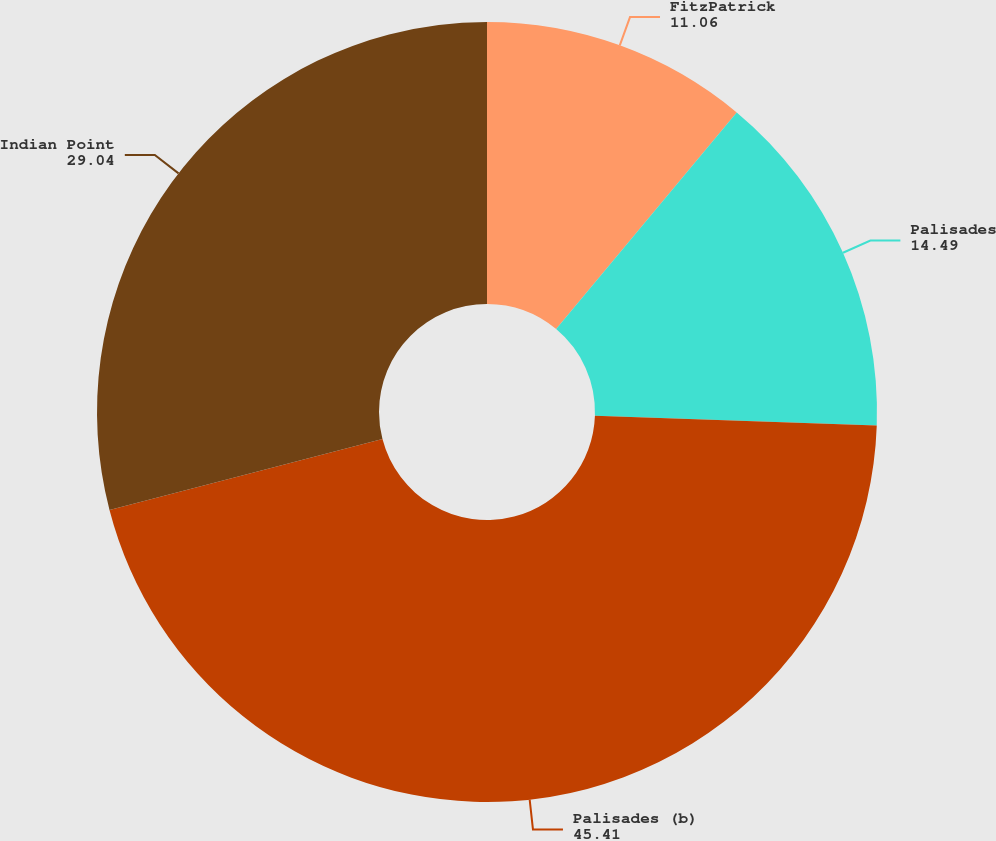Convert chart to OTSL. <chart><loc_0><loc_0><loc_500><loc_500><pie_chart><fcel>FitzPatrick<fcel>Palisades<fcel>Palisades (b)<fcel>Indian Point<nl><fcel>11.06%<fcel>14.49%<fcel>45.41%<fcel>29.04%<nl></chart> 